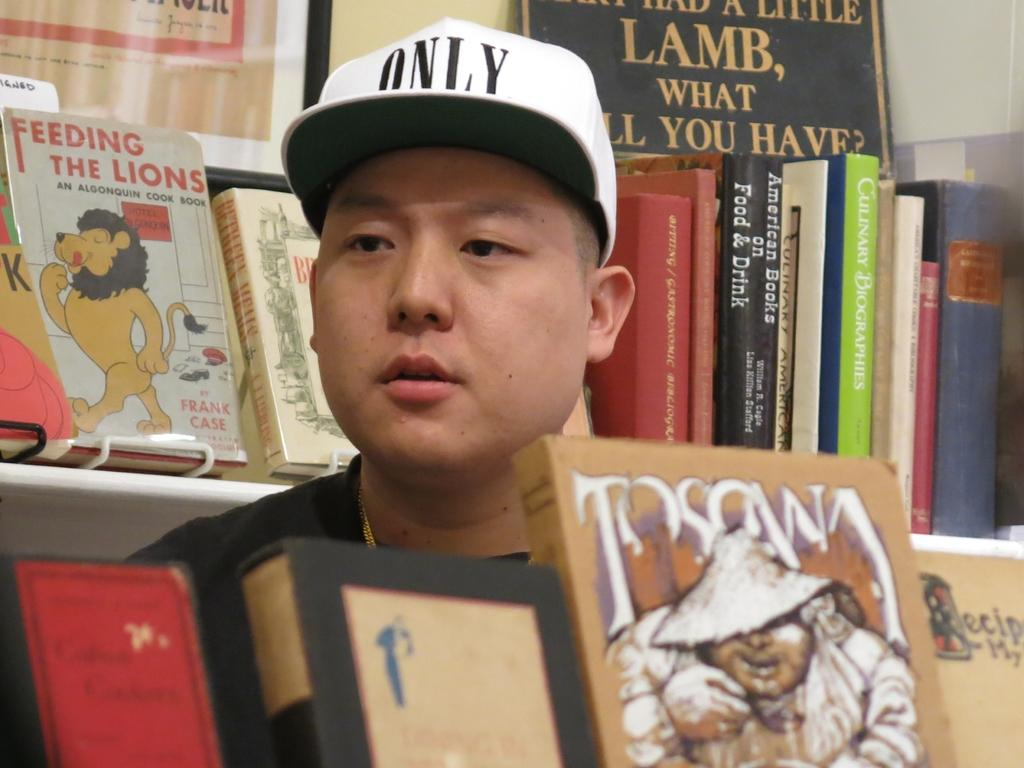<image>
Offer a succinct explanation of the picture presented. Asian Man looking through books in a library, he is wearing an White Only hat. 